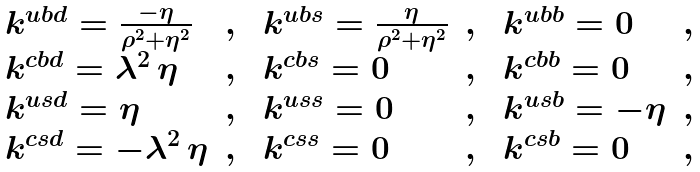<formula> <loc_0><loc_0><loc_500><loc_500>\begin{array} { l c l c l c } \ k ^ { u b d } = \frac { - \eta } { \rho ^ { 2 } + \eta ^ { 2 } } & , & \ k ^ { u b s } = \frac { \eta } { \rho ^ { 2 } + \eta ^ { 2 } } & , & \ k ^ { u b b } = 0 & , \\ \ k ^ { c b d } = \lambda ^ { 2 } \, \eta & , & \ k ^ { c b s } = 0 & , & \ k ^ { c b b } = 0 & , \\ \ k ^ { u s d } = \eta & , & \ k ^ { u s s } = 0 & , & \ k ^ { u s b } = - \eta & , \\ \ k ^ { c s d } = - \lambda ^ { 2 } \, \eta & , & \ k ^ { c s s } = 0 & , & \ k ^ { c s b } = 0 & , \end{array}</formula> 